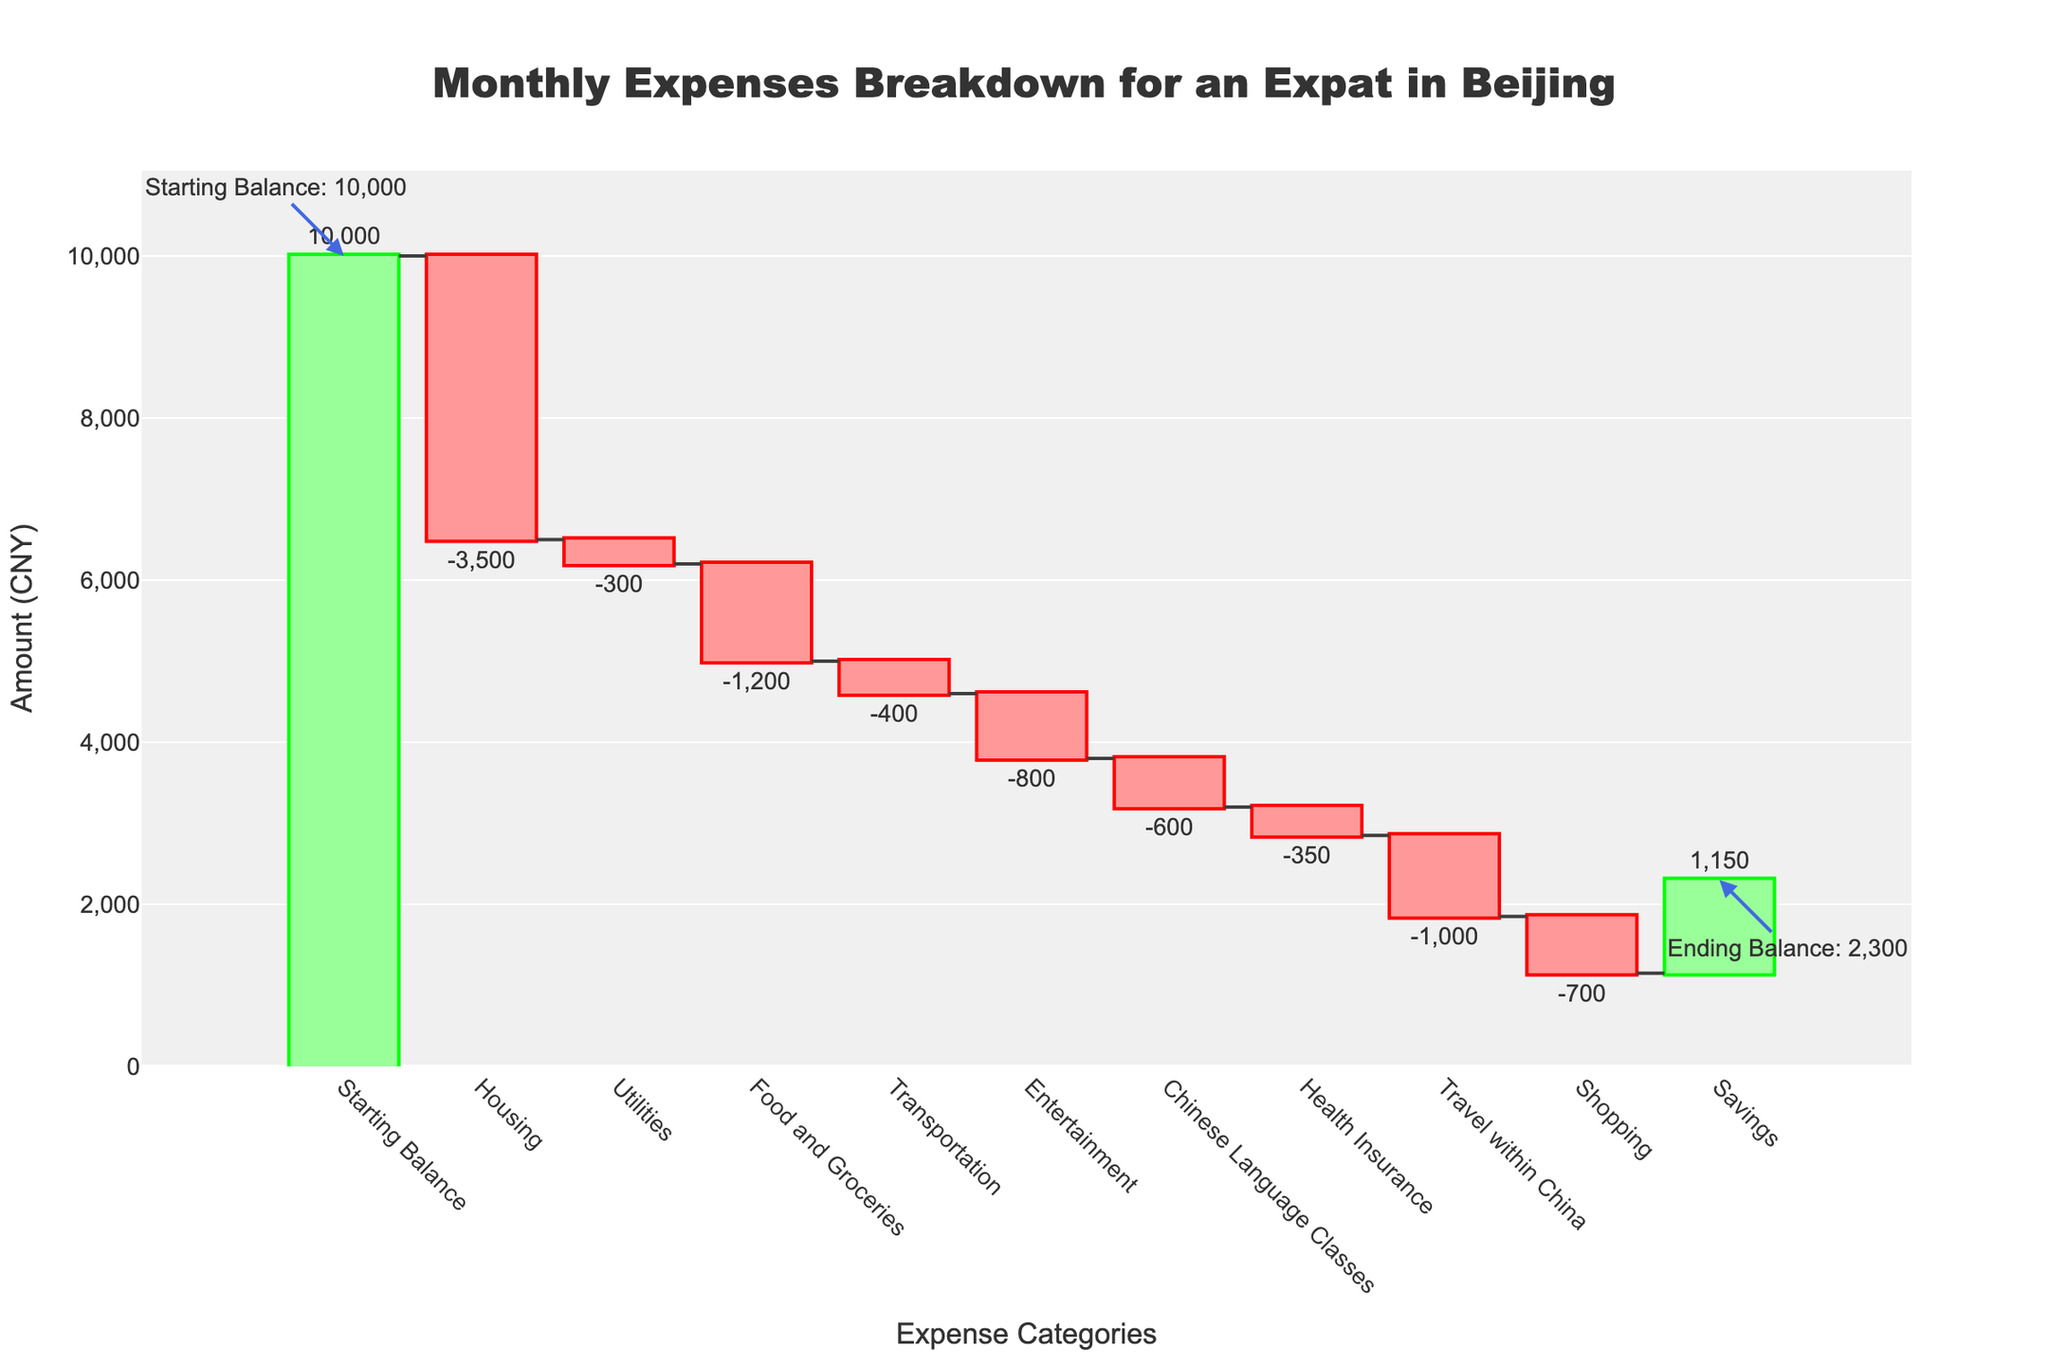What is the total amount spent on Housing? The Housing expense is selected from the series of expense categories and shown as -3500 on the chart.
Answer: -3500 CNY Which category has the largest negative impact on the balance? By comparing the values, Housing has the largest negative amount of -3500.
Answer: Housing What is the cumulative balance after Transportation? To find this, we sum the amounts from the categories Starting Balance, Housing, Utilities, Food and Groceries, and Transportation: 10000 - 3500 - 300 - 1200 - 400 = 4600.
Answer: 4600 CNY What is the cumulative balance after Entertainment? Starting from the Starting Balance and adding up to Entertainment: 10000 - 3500 - 300 - 1200 - 400 - 800 = 3800.
Answer: 3800 CNY What is the ending balance shown in the plot? The Ending Balance is the last data point in the cumulative sum and is labeled on the chart with an annotation.
Answer: 1150 CNY What categories have positive impacts on the balance? The chart shows increase in the Savings category, indicated by the green bar at the end.
Answer: Savings How does the expense on Travel within China compare to Shopping? The chart shows that the Travel within China expense is -1000, while Shopping is -700, thus Travel within China has a larger expense.
Answer: Travel within China has a larger expense What is the difference between the total expenses for Housing and Food and Groceries? The chart illustrates that the expenses for Housing and Food and Groceries are -3500 and -1200 respectively. The difference is -3500 - (-1200) = -2300.
Answer: -2300 CNY What is the cumulative effect of all expenses before Health Insurance? Summing up from Starting Balance to Chinese Language Classes: 10000 - 3500 - 300 - 1200 - 400 - 800 - 600 = 2200.
Answer: 2200 CNY 